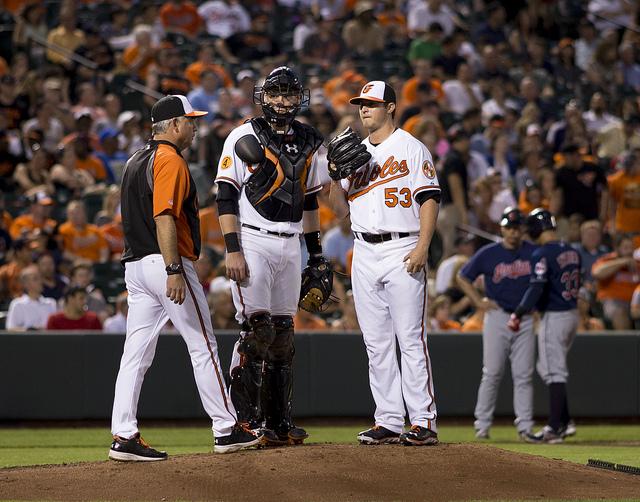Is this a break in the game?
Quick response, please. Yes. What is the color of the player's uniforms?
Quick response, please. White and orange. What is the job of the man facing right?
Short answer required. Coach. Are there any spectators?
Short answer required. Yes. 